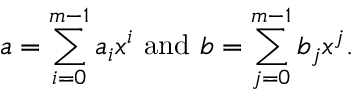Convert formula to latex. <formula><loc_0><loc_0><loc_500><loc_500>a = \sum _ { i = 0 } ^ { m - 1 } { a _ { i } x ^ { i } } { a n d } b = \sum _ { j = 0 } ^ { m - 1 } { b _ { j } x ^ { j } } .</formula> 